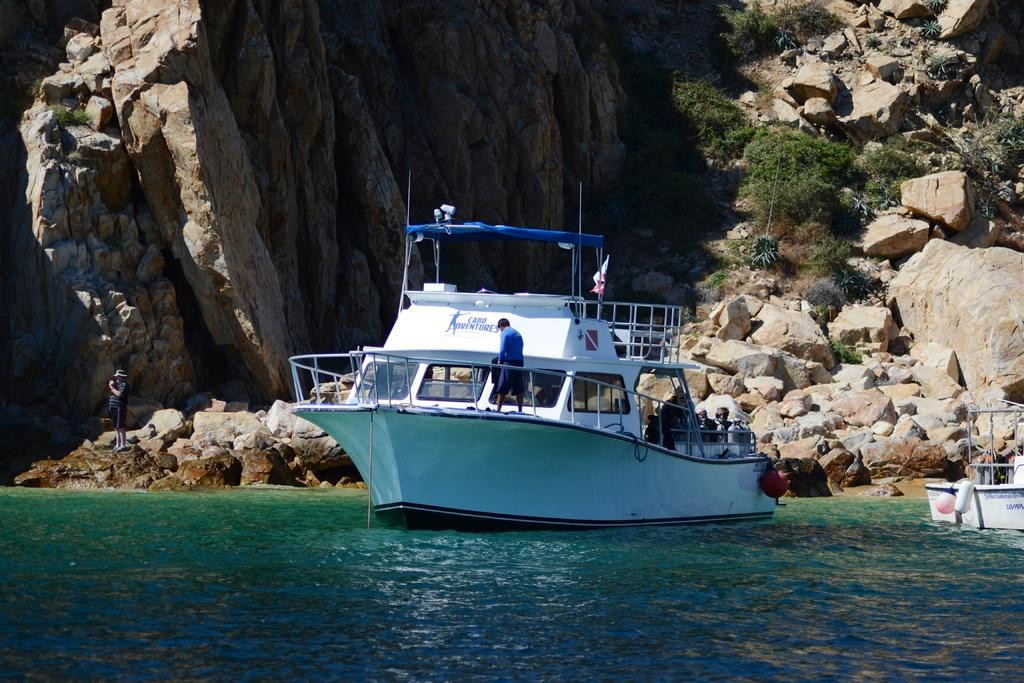<image>
Provide a brief description of the given image. a boat with cabo adventures written on it sits in the ocean near a cliff side 